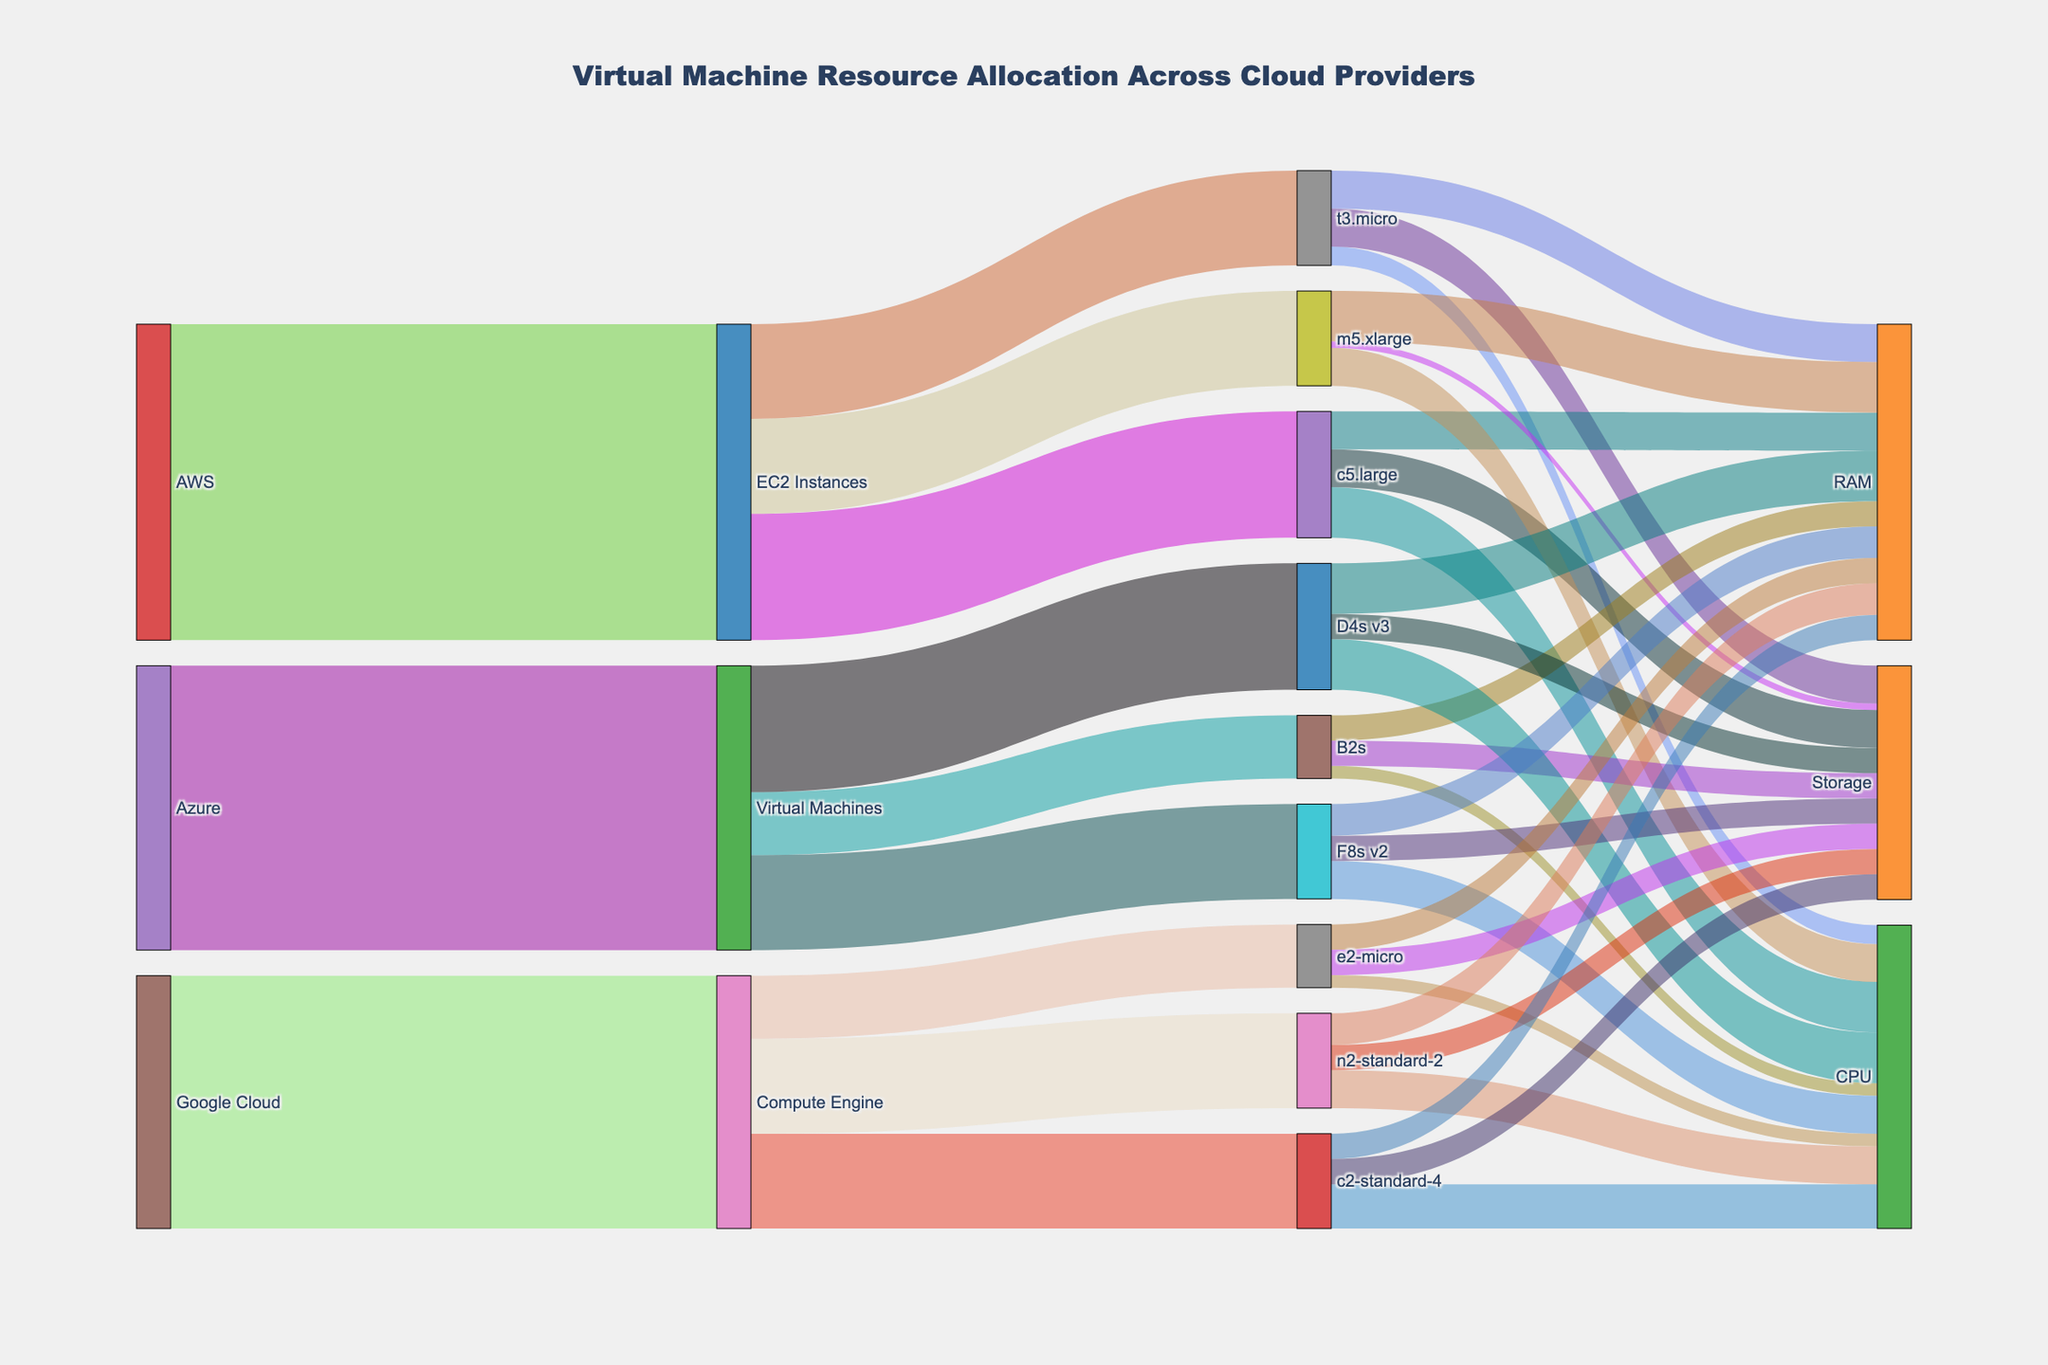What is the title of the Sankey Diagram? The title of the Sankey Diagram is usually placed at the top center of the diagram. From the provided code, the title is specified as "Virtual Machine Resource Allocation Across Cloud Providers."
Answer: Virtual Machine Resource Allocation Across Cloud Providers How many cloud providers are depicted in the diagram? To find the number of cloud providers, you can look at the nodes at the first level of the diagram. According to the data, the sources are AWS, Azure, and Google Cloud.
Answer: 3 Which virtual machine type has the highest allocation under Azure's Virtual Machines? Examine the links coming from "Virtual Machines" under Azure and note their values. D4s v3 has the highest value of 200.
Answer: D4s v3 What is the total allocation of EC2 Instances in AWS? Find the values of allocations from AWS to EC2 Instances by summing up the values of all linkages under EC2 Instances: 150 (t3.micro) + 200 (c5.large) + 150 (m5.xlarge) = 500.
Answer: 500 How is the resource allocation for t3.micro distributed? Look at the links coming out of t3.micro to find the resource distribution. The values are 30 (CPU), 60 (RAM), and 60 (Storage).
Answer: 30 (CPU), 60 (RAM), and 60 (Storage) Which VM type in Google Cloud has the highest allocation? Examine the allocations under Google Cloud's Compute Engine. The values are 100 (e2-micro), 150 (n2-standard-2), and 150 (c2-standard-4). Both n2-standard-2 and c2-standard-4 have the highest, which is 150.
Answer: n2-standard-2 and c2-standard-4 What is the average allocation value per resource for EC2 Instances' c5.large? Look at the resource allocation values for CPU, RAM, and Storage under c5.large and calculate the average. (80 + 60 + 60) / 3 = 200 / 3 ≈ 66.67
Answer: 66.67 Compare the total resource allocation for CPU across all VM types under AWS EC2 Instances to Azure Virtual Machines. Which is higher? First, sum up all CPU allocations for AWS: 30 (t3.micro) + 80 (c5.large) + 60 (m5.xlarge) = 170. Then for Azure: 20 (B2s) + 80 (D4s v3) + 60 (F8s v2) = 160. 170 (AWS) is higher than 160 (Azure).
Answer: AWS How many types of resources are allocated for each VM type? Each VM type (like t3.micro, c5.large, etc.) has three types of resources allocated: CPU, RAM, and Storage.
Answer: 3 Which specific resource under Google Cloud's c2-standard-4 has the highest value? Look at the resource allocation values for c2-standard-4: 70 (CPU), 40 (RAM), and 40 (Storage). CPU has the highest value, which is 70.
Answer: CPU 